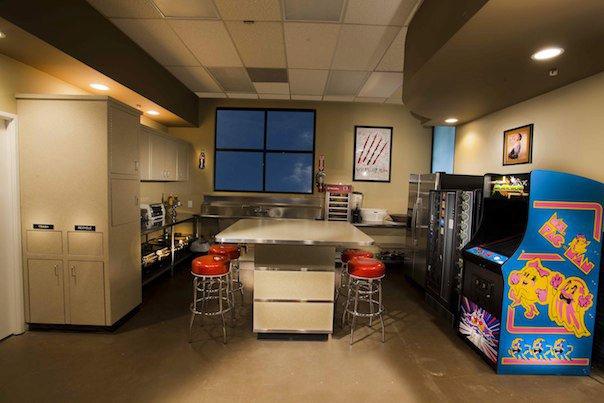Is the window open?
Short answer required. No. What are the words on the arcade game?
Answer briefly. Ms pac man. What kind of seats are under the counter?
Write a very short answer. Stools. 